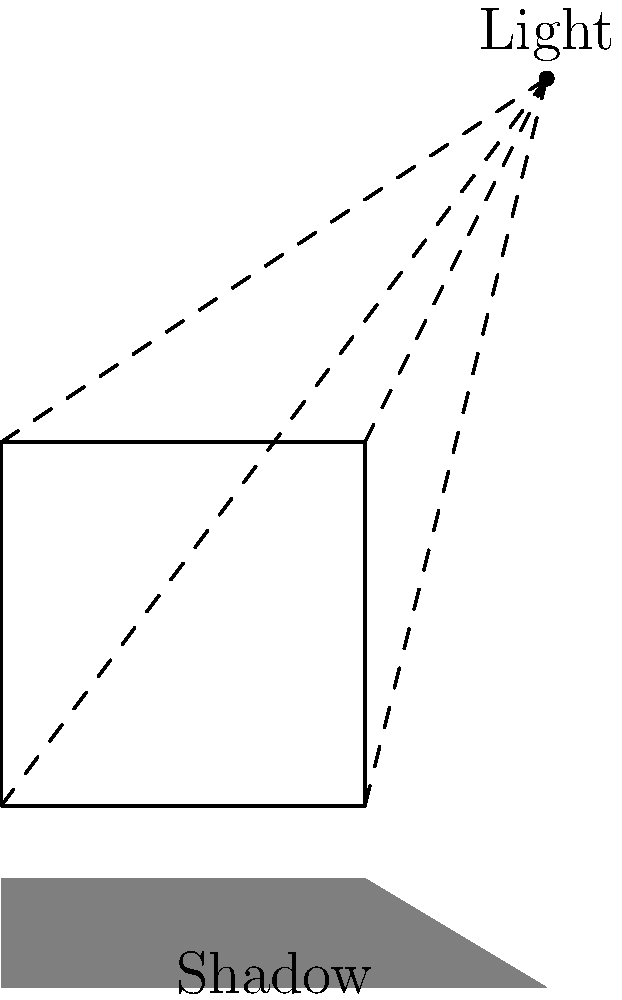In the diagram above, a simple 2D representation of a cube is illuminated by a single light source. Based on the light rays and resulting shadow, which lighting technique is most likely being demonstrated, and how might this affect the perceived realism in a modern game engine? To answer this question, let's break down the key elements of the diagram and their implications for game graphics:

1. Light source: The diagram shows a single, point light source above and to the right of the cube.

2. Light rays: Dashed lines represent light rays emanating from the source to the cube's vertices.

3. Shadow: A gray area below the cube represents its shadow.

4. Cube representation: The cube is shown as a 2D square, which is a simplified version of a 3D object.

Given these elements, we can deduce that the lighting technique being demonstrated is most likely shadow mapping. Here's why:

1. Single light source: Shadow mapping typically uses a single light source to calculate shadows.

2. Hard shadow edges: The shadow in the diagram has sharp, defined edges, which is characteristic of basic shadow mapping.

3. Simplified geometry: The use of a 2D representation suggests that the technique focuses on the relationship between the light source and object surfaces, which is fundamental to shadow mapping.

In a modern game engine, this basic shadow mapping technique would affect perceived realism in the following ways:

1. Performance: Shadow mapping is relatively efficient, allowing for real-time shadow calculations in complex scenes.

2. Limited soft shadows: Basic shadow mapping produces hard-edged shadows, which can look unrealistic in many scenarios.

3. Aliasing: The technique can suffer from aliasing artifacts, especially at shadow edges.

4. Limited indirect lighting: This method doesn't account for indirect lighting or global illumination, reducing overall scene realism.

To enhance realism, modern engines often use variations of shadow mapping, such as:

1. Percentage Closer Filtering (PCF) for softer shadow edges
2. Cascaded Shadow Maps for large outdoor environments
3. Variance Shadow Maps for better performance and quality

These advanced techniques aim to address the limitations of basic shadow mapping while maintaining real-time performance, crucial for immersive gaming experiences.
Answer: Shadow mapping; limits realism due to hard edges and lack of indirect lighting. 